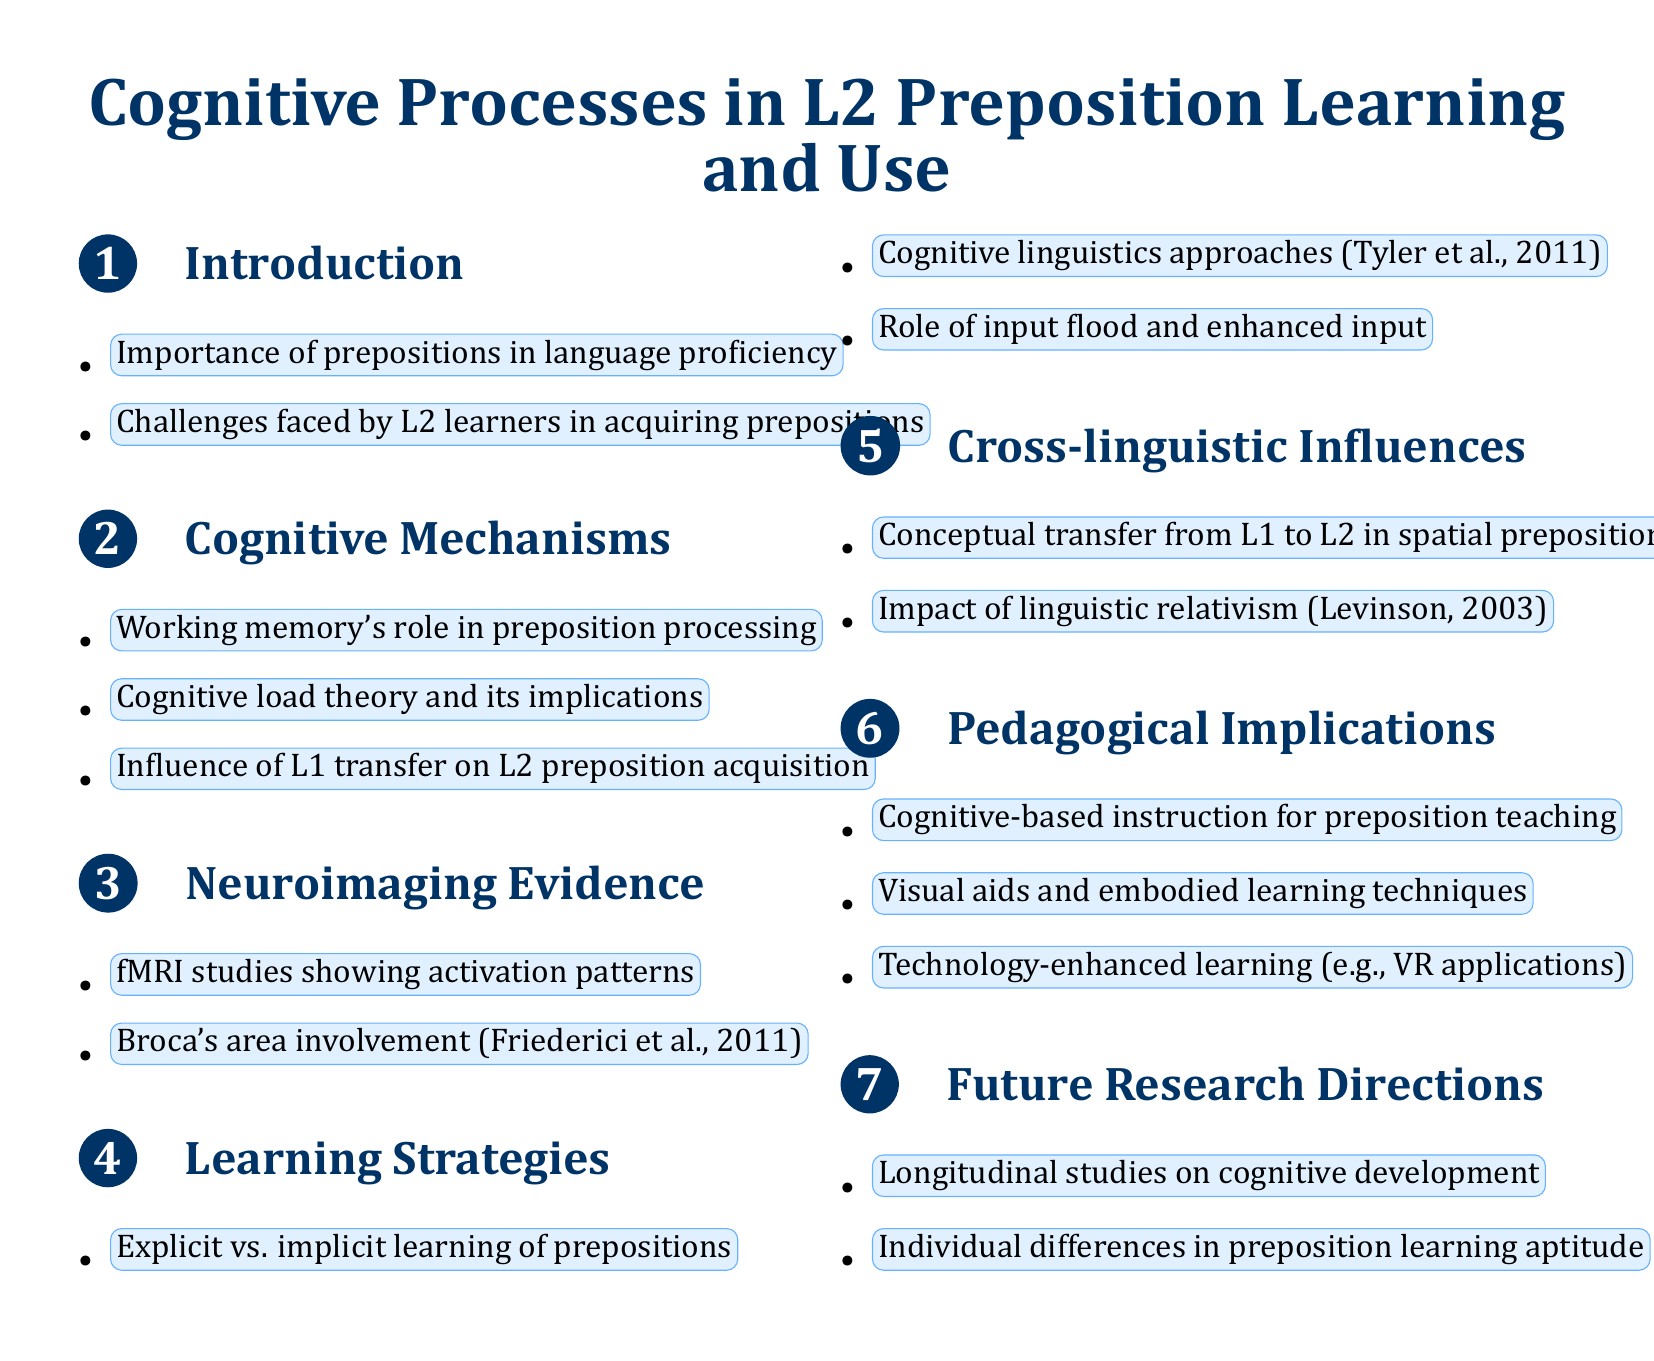What is the title of the document? The title of the document is the first text presented in the rendered document, summarizing the main topic.
Answer: Cognitive Processes in L2 Preposition Learning and Use What cognitive mechanism is highlighted in the document? The document emphasizes several cognitive mechanisms under one section; a notable one is working memory.
Answer: Working memory's role in preposition processing Which area of the brain is involved in preposition processing according to the evidence? The neuroimaging evidence section mentions a specific brain area that is crucial in processing prepositions.
Answer: Broca's area What type of instruction is recommended for teaching prepositions? The pedagogical implications section suggests a specific instructional approach that is grounded in cognitive principles.
Answer: Cognitive-based instruction for preposition teaching What influences L2 preposition acquisition as per the document? The cognitive mechanisms section references the impact of a learner's first language on acquiring prepositions in a second language.
Answer: L1 transfer What future research direction is mentioned regarding preposition acquisition? The final section discusses a type of study that could further explore the cognitive aspects over time related to preposition use.
Answer: Longitudinal studies on cognitive development What learning strategies are compared in the document? The document contrasts two distinct methods for learning prepositions, focusing on their dynamics in learning contexts.
Answer: Explicit vs. implicit learning of prepositions What type of applications are suggested for technology-enhanced learning? The pedagogical implications section presents examples of modern technological tools that could assist in learning prepositions.
Answer: VR applications What concept is mentioned regarding spatial prepositions in cross-linguistic influences? The document discusses a specific type of transfer between languages that affects spatial prepositions.
Answer: Conceptual transfer from L1 to L2 in spatial prepositions 